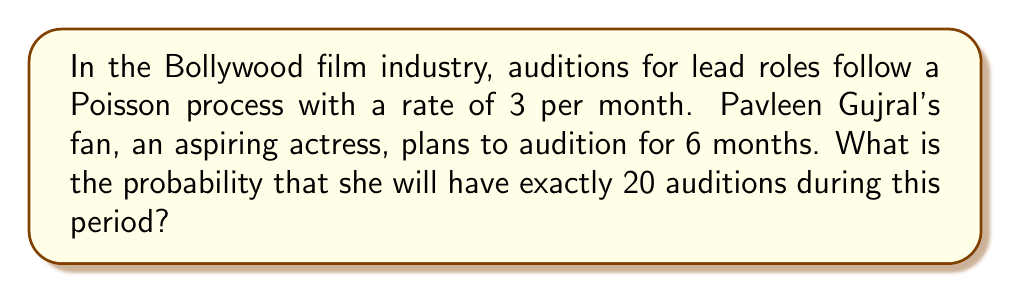Could you help me with this problem? Let's approach this step-by-step:

1) We are dealing with a Poisson process, where:
   - The rate (λ) is 3 auditions per month
   - The time period (t) is 6 months
   - We want the probability of exactly 20 auditions (k = 20)

2) For a Poisson process, the number of events in a fixed time interval follows a Poisson distribution. The probability mass function for a Poisson distribution is:

   $$P(X = k) = \frac{e^{-\lambda t}(\lambda t)^k}{k!}$$

3) We need to calculate λt:
   $$\lambda t = 3 \text{ auditions/month} \times 6 \text{ months} = 18$$

4) Now, let's substitute our values into the Poisson probability mass function:

   $$P(X = 20) = \frac{e^{-18}(18)^{20}}{20!}$$

5) We can calculate this using a calculator or computer:

   $$P(X = 20) \approx 0.0516$$

This means there is approximately a 5.16% chance of having exactly 20 auditions in 6 months.
Answer: 0.0516 